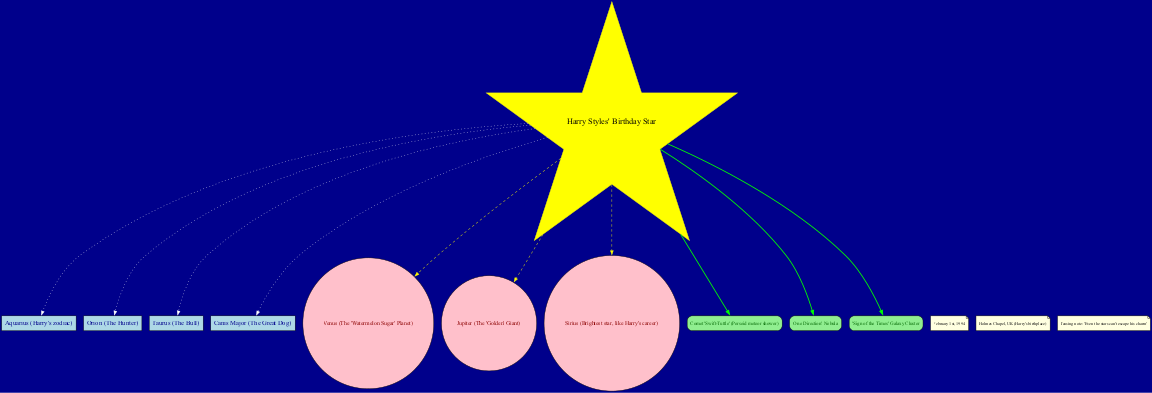What is the center object in the diagram? The center object in the diagram is indicated as "Harry Styles' Birthday Star", which is the focal point for the other nodes around it.
Answer: Harry Styles' Birthday Star How many constellations are highlighted in the diagram? By counting the nodes labeled with constellations, there are four: Aquarius, Orion, Taurus, and Canis Major.
Answer: 4 Which celestial object is described as the "Watermelon Sugar" planet? The celestial object specifically labeled as the "Watermelon Sugar" planet corresponds to Venus, as mentioned in the data provided for the diagram.
Answer: Venus What is the name of the special feature that refers to a meteor shower? The special feature that refers to a meteor shower is labeled as "Comet 'Swift-Tuttle' (Perseid meteor shower)", indicating its significance in the context of the diagram.
Answer: Comet 'Swift-Tuttle' Which constellation is associated with Harry Styles' zodiac? The diagram highlights Aquarius as Harry Styles' zodiac, as it is explicitly listed among the constellations in the data.
Answer: Aquarius How many special features are included in the diagram? The special features section contains three items: Comet 'Swift-Tuttle', 'One Direction' Nebula, and 'Sign of the Times' Galaxy Cluster, which can be counted directly from the list.
Answer: 3 What is the annotation that teases Harry Styles' charm? The annotation stating that "Even the stars can't escape his charm" is included to humorously highlight Harry's appeal, which can be noted from the annotations in the diagram.
Answer: Even the stars can't escape his charm Which celestial object in the diagram is the brightest star? The celestial object identified as the brightest star in the diagram is Sirius, mentioned as a significant point in relation to Harry Styles' career.
Answer: Sirius 